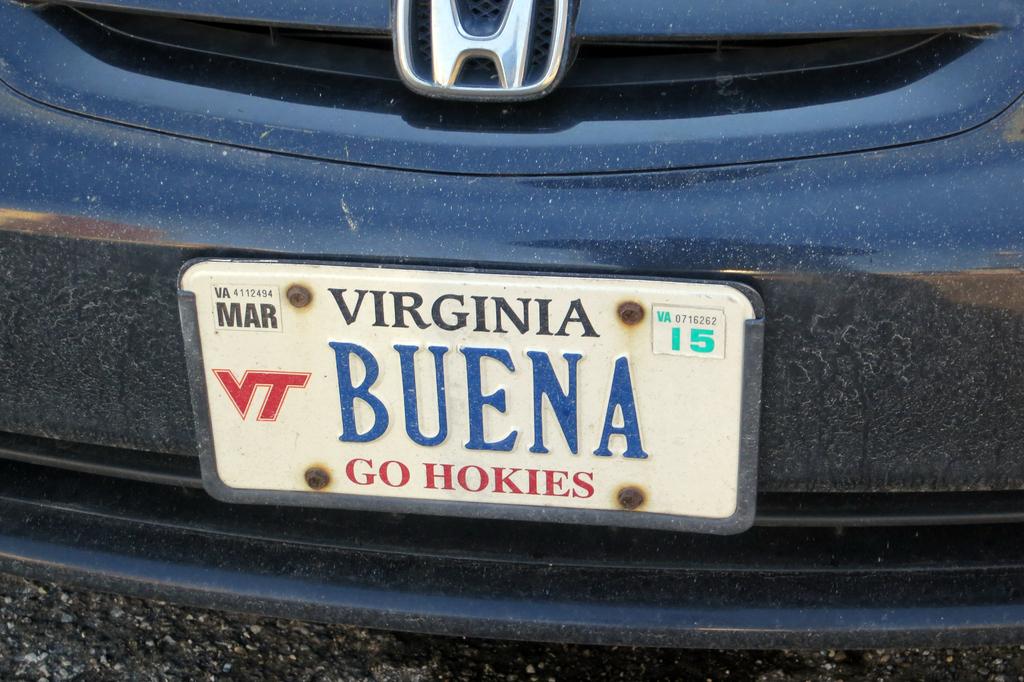In what month does this tag expire?
Ensure brevity in your answer.  March. What state is the license plate issued in?
Make the answer very short. Virginia. 